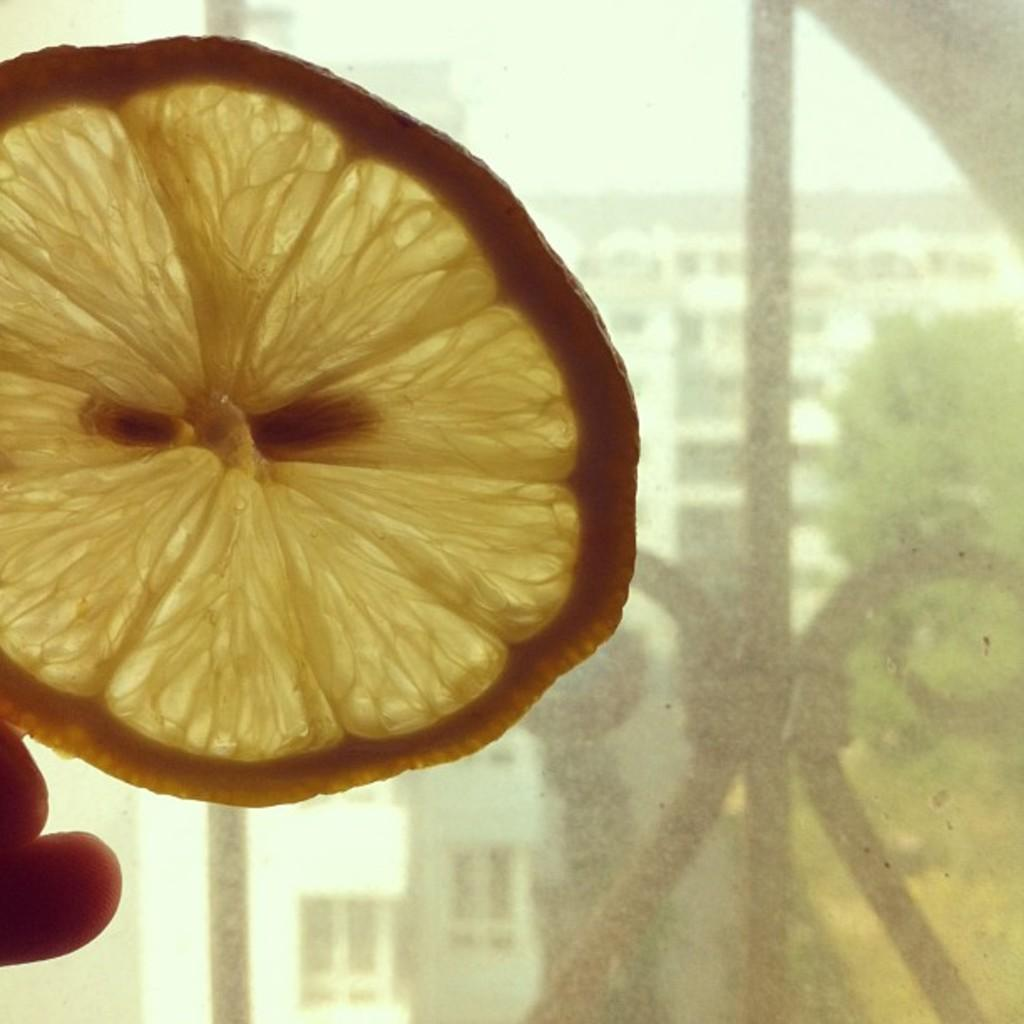What type of fruit can be seen in the image? There is a slice of a lemon in the image. Whose fingers are visible in the image? The fingers of a person are visible in the image. What type of objects are made of metal in the image? There are metal objects in the image. What type of structures can be seen in the image? There are buildings in the image. What type of vegetation is present in the image? There are trees in the image. What part of the natural environment is visible in the image? The sky is visible in the image. What type of appliance is causing the disease in the image? There is no appliance or disease present in the image. What type of fuel is being used by the coal-powered vehicle in the image? There is no coal-powered vehicle present in the image. 